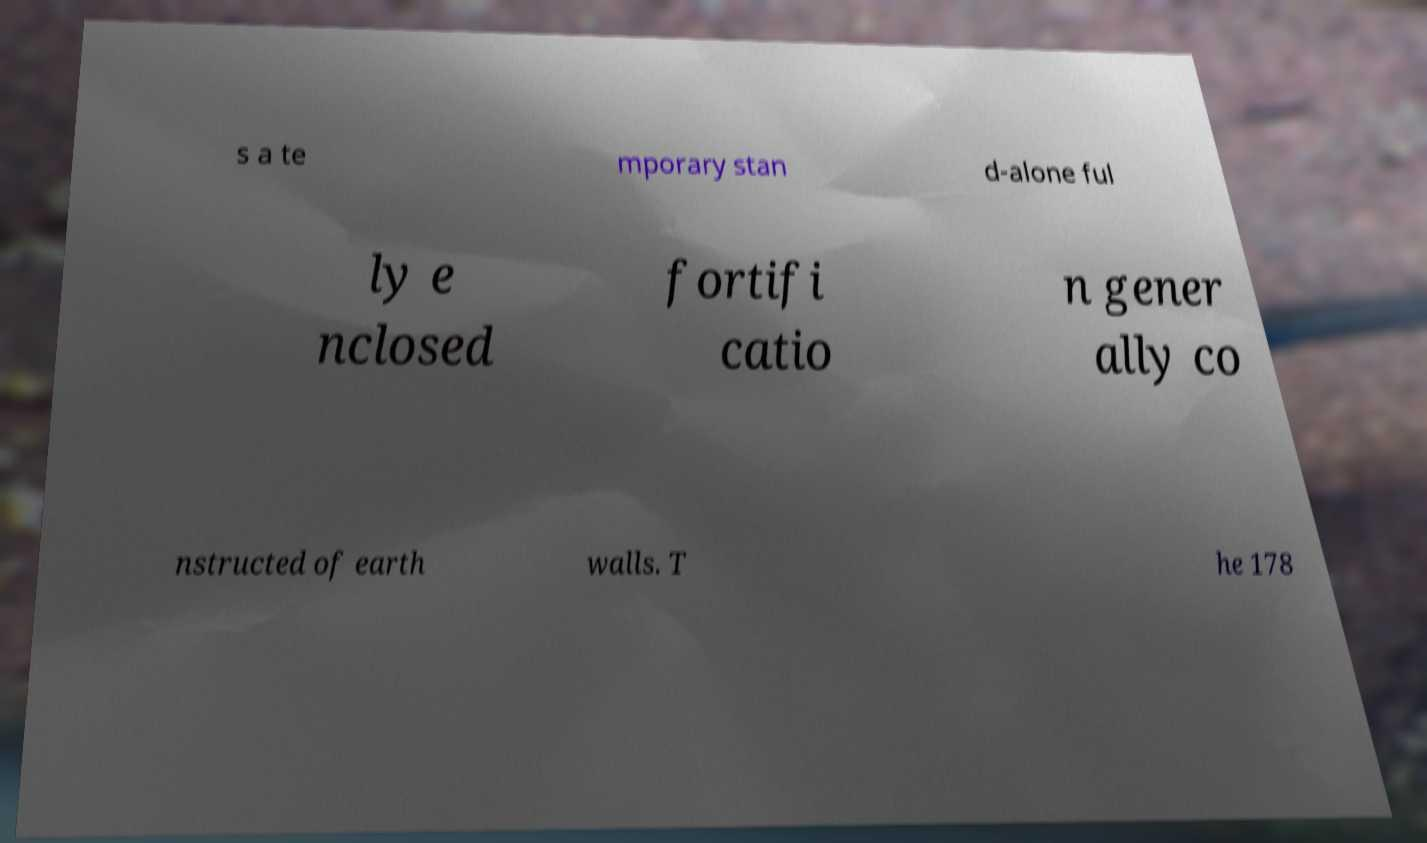Please read and relay the text visible in this image. What does it say? s a te mporary stan d-alone ful ly e nclosed fortifi catio n gener ally co nstructed of earth walls. T he 178 